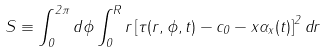Convert formula to latex. <formula><loc_0><loc_0><loc_500><loc_500>S \equiv \int _ { 0 } ^ { 2 \pi } d \phi \int _ { 0 } ^ { R } r \left [ \tau ( r , \phi , t ) - c _ { 0 } - x \alpha _ { x } ( t ) \right ] ^ { 2 } d r</formula> 